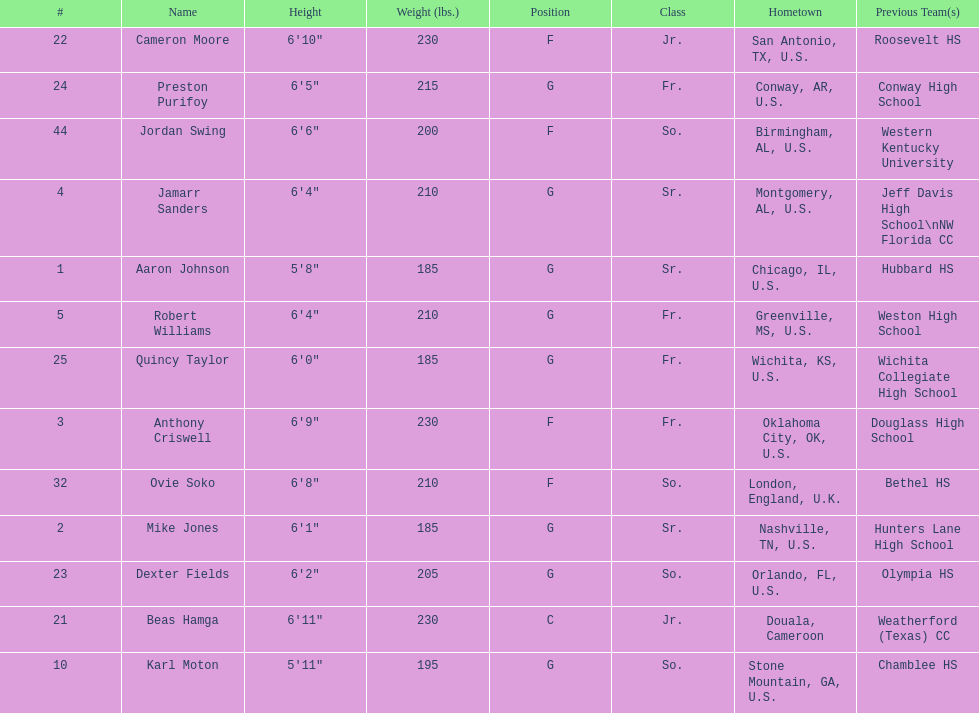Who is first on the roster? Aaron Johnson. 